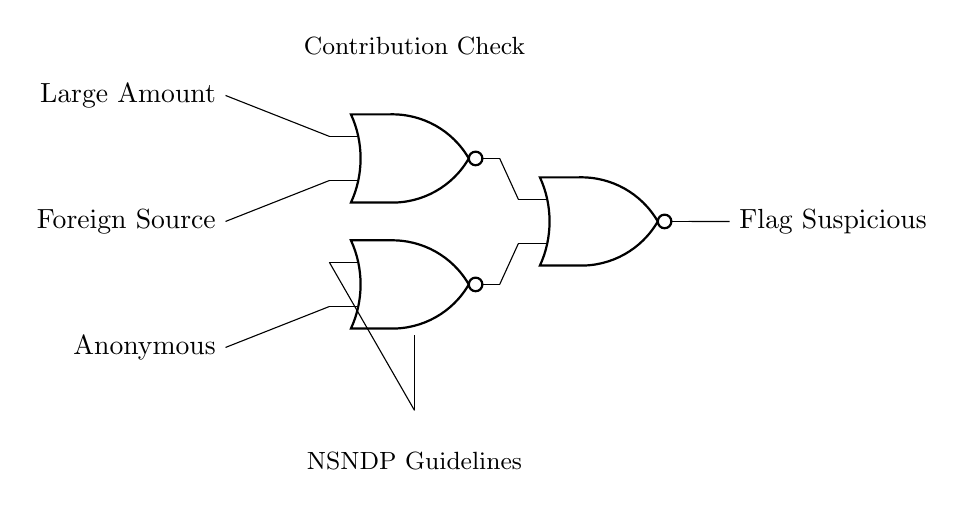What are the input signals for the circuit? The circuit diagram shows three input signals labeled as "Large Amount," "Foreign Source," and "Anonymous." These inputs feed into the NOR gates to determine the output.
Answer: Large Amount, Foreign Source, Anonymous How many NOR gates are present in the circuit? Upon inspecting the circuit, we see that there are three distinct NOR gates connected in a specific manner.
Answer: Three What is the output of the circuit? The output from the circuit is labeled "Flag Suspicious," indicating that the processing of the inputs results in a flag being raised for suspicious contributions.
Answer: Flag Suspicious How does the first NOR gate contribute to the output? The first NOR gate takes inputs from "Large Amount" and "Foreign Source." If either of these inputs is true (logical high), the output will be low; otherwise, it contributes to the next NOR gate's input.
Answer: It contributes by outputting based on "Large Amount" and "Foreign Source." What happens when all inputs are low? If all input signals are low (meaning no large amount, no foreign source, and no anonymous contributions), the first NOR gate will output a high signal, which then influences subsequent NOR gates. This behavior follows the logic of NOR gates, where the output is high only if all inputs are low.
Answer: Output will be high How many inputs does the last NOR gate receive? The last NOR gate, placed in the circuit, receives signals from both the first NOR gate and the second NOR gate. This means it has two inputs which determine its final output based on the conditions applied by the previous gates.
Answer: Two 